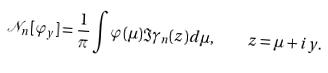Convert formula to latex. <formula><loc_0><loc_0><loc_500><loc_500>\mathcal { N } _ { n } [ \varphi _ { y } ] = \frac { 1 } { \pi } \int \varphi ( \mu ) \Im \gamma _ { n } ( z ) d \mu , \quad z = \mu + i y .</formula> 